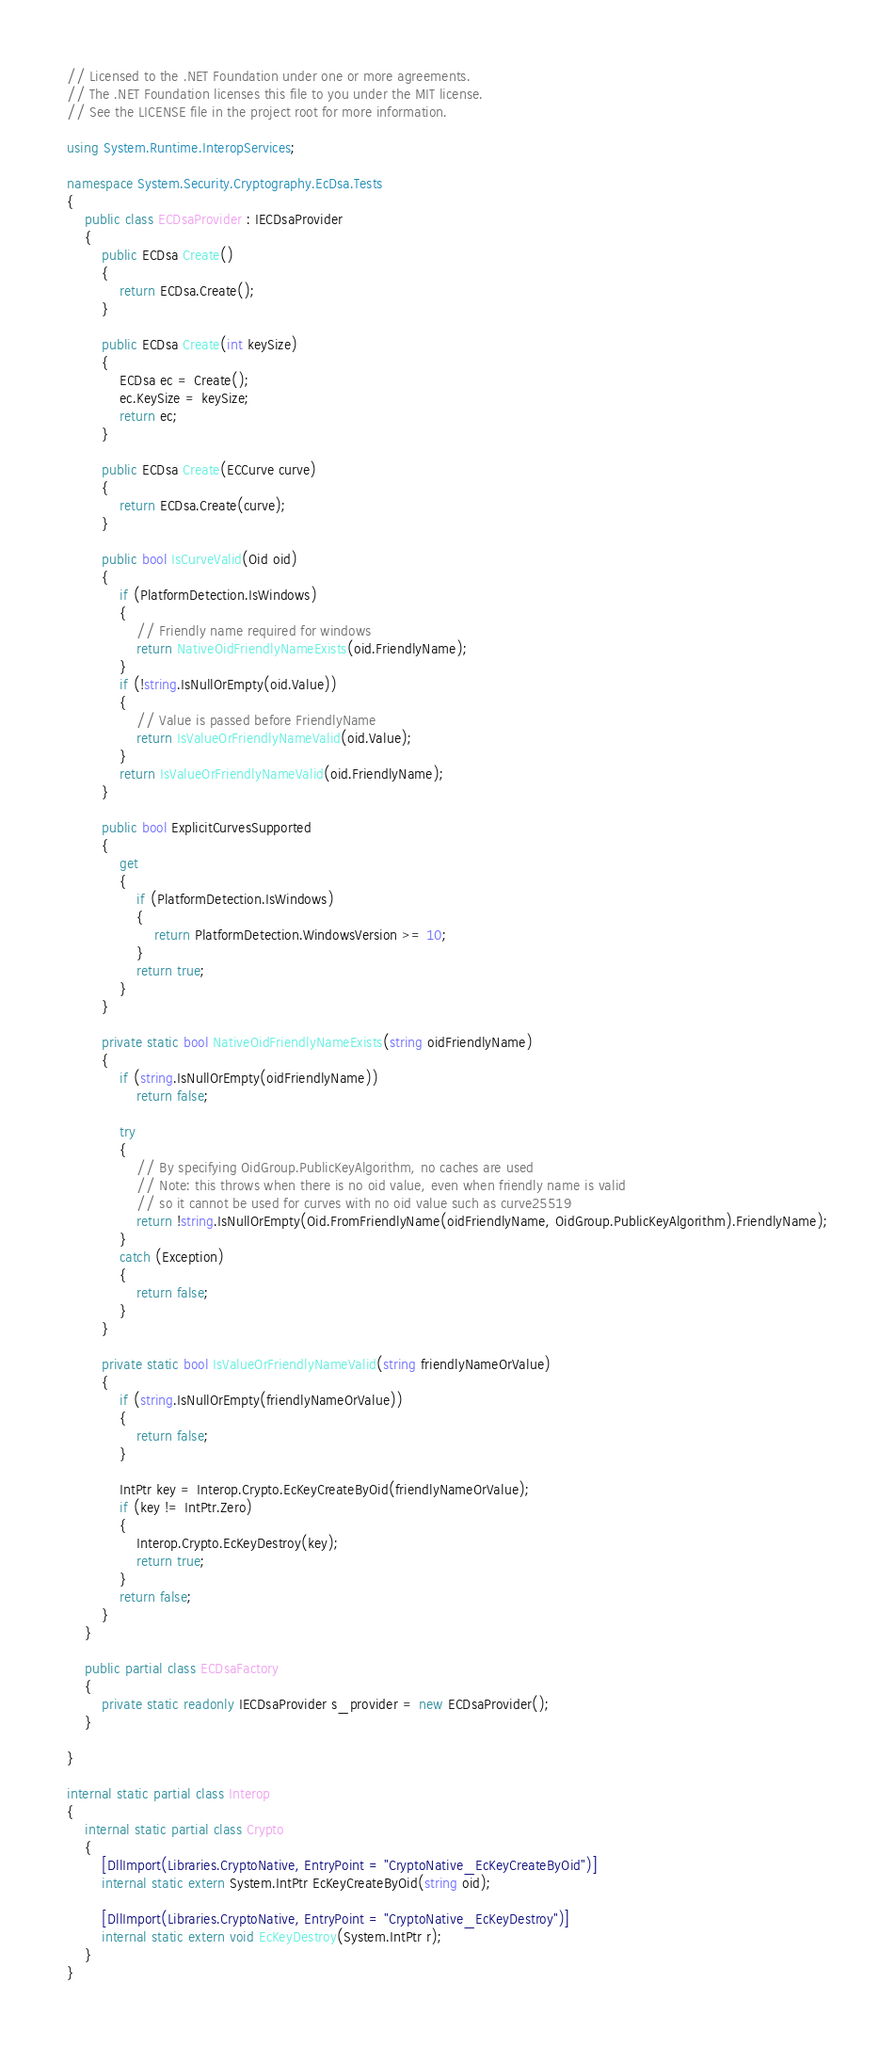Convert code to text. <code><loc_0><loc_0><loc_500><loc_500><_C#_>// Licensed to the .NET Foundation under one or more agreements.
// The .NET Foundation licenses this file to you under the MIT license.
// See the LICENSE file in the project root for more information.

using System.Runtime.InteropServices;

namespace System.Security.Cryptography.EcDsa.Tests
{
    public class ECDsaProvider : IECDsaProvider
    {
        public ECDsa Create()
        {
            return ECDsa.Create();
        }

        public ECDsa Create(int keySize)
        {
            ECDsa ec = Create();
            ec.KeySize = keySize;
            return ec;
        }

        public ECDsa Create(ECCurve curve)
        {
            return ECDsa.Create(curve);
        }

        public bool IsCurveValid(Oid oid)
        {
            if (PlatformDetection.IsWindows)
            {
                // Friendly name required for windows
                return NativeOidFriendlyNameExists(oid.FriendlyName);
            }
            if (!string.IsNullOrEmpty(oid.Value))
            {
                // Value is passed before FriendlyName
                return IsValueOrFriendlyNameValid(oid.Value);
            }
            return IsValueOrFriendlyNameValid(oid.FriendlyName);
        }

        public bool ExplicitCurvesSupported
        {
            get
            {
                if (PlatformDetection.IsWindows)
                {
                    return PlatformDetection.WindowsVersion >= 10;
                }
                return true;
            }
        }

        private static bool NativeOidFriendlyNameExists(string oidFriendlyName)
        {
            if (string.IsNullOrEmpty(oidFriendlyName))
                return false;

            try
            {
                // By specifying OidGroup.PublicKeyAlgorithm, no caches are used
                // Note: this throws when there is no oid value, even when friendly name is valid
                // so it cannot be used for curves with no oid value such as curve25519
                return !string.IsNullOrEmpty(Oid.FromFriendlyName(oidFriendlyName, OidGroup.PublicKeyAlgorithm).FriendlyName);
            }
            catch (Exception)
            {
                return false;
            }
        }

        private static bool IsValueOrFriendlyNameValid(string friendlyNameOrValue)
        {
            if (string.IsNullOrEmpty(friendlyNameOrValue))
            {
                return false;
            }

            IntPtr key = Interop.Crypto.EcKeyCreateByOid(friendlyNameOrValue);
            if (key != IntPtr.Zero)
            {
                Interop.Crypto.EcKeyDestroy(key);
                return true;
            }
            return false;
        }
    }

    public partial class ECDsaFactory
    {
        private static readonly IECDsaProvider s_provider = new ECDsaProvider();
    }

}

internal static partial class Interop
{
    internal static partial class Crypto
    {
        [DllImport(Libraries.CryptoNative, EntryPoint = "CryptoNative_EcKeyCreateByOid")]
        internal static extern System.IntPtr EcKeyCreateByOid(string oid);

        [DllImport(Libraries.CryptoNative, EntryPoint = "CryptoNative_EcKeyDestroy")]
        internal static extern void EcKeyDestroy(System.IntPtr r);
    }
}
</code> 